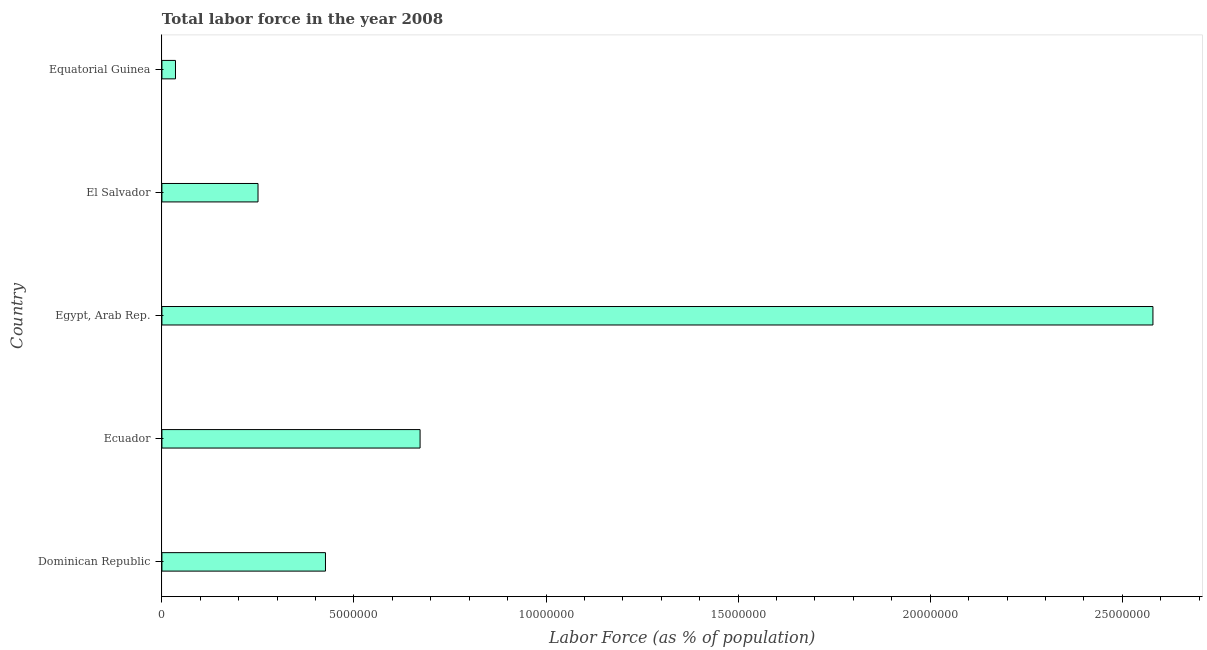Does the graph contain any zero values?
Your answer should be very brief. No. What is the title of the graph?
Keep it short and to the point. Total labor force in the year 2008. What is the label or title of the X-axis?
Make the answer very short. Labor Force (as % of population). What is the label or title of the Y-axis?
Offer a terse response. Country. What is the total labor force in El Salvador?
Keep it short and to the point. 2.50e+06. Across all countries, what is the maximum total labor force?
Your answer should be very brief. 2.58e+07. Across all countries, what is the minimum total labor force?
Your response must be concise. 3.54e+05. In which country was the total labor force maximum?
Provide a succinct answer. Egypt, Arab Rep. In which country was the total labor force minimum?
Keep it short and to the point. Equatorial Guinea. What is the sum of the total labor force?
Your response must be concise. 3.96e+07. What is the difference between the total labor force in El Salvador and Equatorial Guinea?
Your answer should be compact. 2.15e+06. What is the average total labor force per country?
Make the answer very short. 7.93e+06. What is the median total labor force?
Give a very brief answer. 4.26e+06. In how many countries, is the total labor force greater than 3000000 %?
Ensure brevity in your answer.  3. What is the ratio of the total labor force in Egypt, Arab Rep. to that in El Salvador?
Make the answer very short. 10.31. What is the difference between the highest and the second highest total labor force?
Offer a very short reply. 1.91e+07. What is the difference between the highest and the lowest total labor force?
Your answer should be compact. 2.54e+07. Are all the bars in the graph horizontal?
Make the answer very short. Yes. How many countries are there in the graph?
Your answer should be compact. 5. What is the difference between two consecutive major ticks on the X-axis?
Give a very brief answer. 5.00e+06. Are the values on the major ticks of X-axis written in scientific E-notation?
Ensure brevity in your answer.  No. What is the Labor Force (as % of population) of Dominican Republic?
Offer a very short reply. 4.26e+06. What is the Labor Force (as % of population) in Ecuador?
Ensure brevity in your answer.  6.72e+06. What is the Labor Force (as % of population) in Egypt, Arab Rep.?
Your response must be concise. 2.58e+07. What is the Labor Force (as % of population) of El Salvador?
Make the answer very short. 2.50e+06. What is the Labor Force (as % of population) of Equatorial Guinea?
Your response must be concise. 3.54e+05. What is the difference between the Labor Force (as % of population) in Dominican Republic and Ecuador?
Your answer should be very brief. -2.46e+06. What is the difference between the Labor Force (as % of population) in Dominican Republic and Egypt, Arab Rep.?
Make the answer very short. -2.15e+07. What is the difference between the Labor Force (as % of population) in Dominican Republic and El Salvador?
Offer a very short reply. 1.76e+06. What is the difference between the Labor Force (as % of population) in Dominican Republic and Equatorial Guinea?
Provide a short and direct response. 3.90e+06. What is the difference between the Labor Force (as % of population) in Ecuador and Egypt, Arab Rep.?
Your response must be concise. -1.91e+07. What is the difference between the Labor Force (as % of population) in Ecuador and El Salvador?
Ensure brevity in your answer.  4.22e+06. What is the difference between the Labor Force (as % of population) in Ecuador and Equatorial Guinea?
Make the answer very short. 6.37e+06. What is the difference between the Labor Force (as % of population) in Egypt, Arab Rep. and El Salvador?
Your response must be concise. 2.33e+07. What is the difference between the Labor Force (as % of population) in Egypt, Arab Rep. and Equatorial Guinea?
Keep it short and to the point. 2.54e+07. What is the difference between the Labor Force (as % of population) in El Salvador and Equatorial Guinea?
Give a very brief answer. 2.15e+06. What is the ratio of the Labor Force (as % of population) in Dominican Republic to that in Ecuador?
Keep it short and to the point. 0.63. What is the ratio of the Labor Force (as % of population) in Dominican Republic to that in Egypt, Arab Rep.?
Provide a succinct answer. 0.17. What is the ratio of the Labor Force (as % of population) in Dominican Republic to that in El Salvador?
Your answer should be compact. 1.7. What is the ratio of the Labor Force (as % of population) in Dominican Republic to that in Equatorial Guinea?
Offer a very short reply. 12.04. What is the ratio of the Labor Force (as % of population) in Ecuador to that in Egypt, Arab Rep.?
Offer a terse response. 0.26. What is the ratio of the Labor Force (as % of population) in Ecuador to that in El Salvador?
Keep it short and to the point. 2.69. What is the ratio of the Labor Force (as % of population) in Ecuador to that in Equatorial Guinea?
Give a very brief answer. 19. What is the ratio of the Labor Force (as % of population) in Egypt, Arab Rep. to that in El Salvador?
Make the answer very short. 10.31. What is the ratio of the Labor Force (as % of population) in Egypt, Arab Rep. to that in Equatorial Guinea?
Your response must be concise. 72.95. What is the ratio of the Labor Force (as % of population) in El Salvador to that in Equatorial Guinea?
Provide a succinct answer. 7.08. 